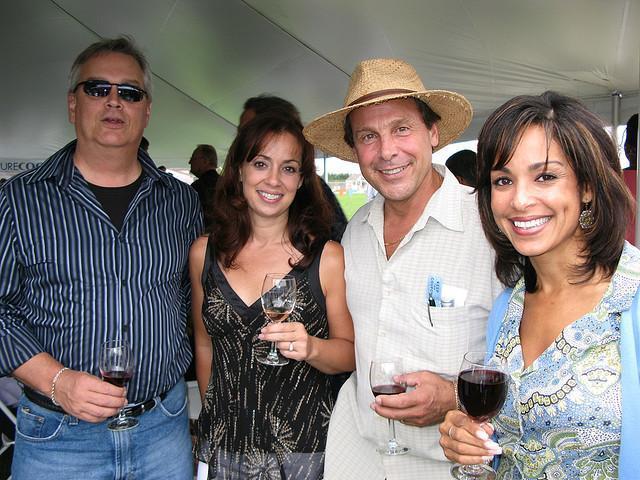How many men are in the photo?
Give a very brief answer. 2. How many people are there?
Give a very brief answer. 4. 